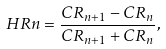<formula> <loc_0><loc_0><loc_500><loc_500>H R n = \frac { C R _ { n + 1 } - C R _ { n } } { C R _ { n + 1 } + C R _ { n } } ,</formula> 